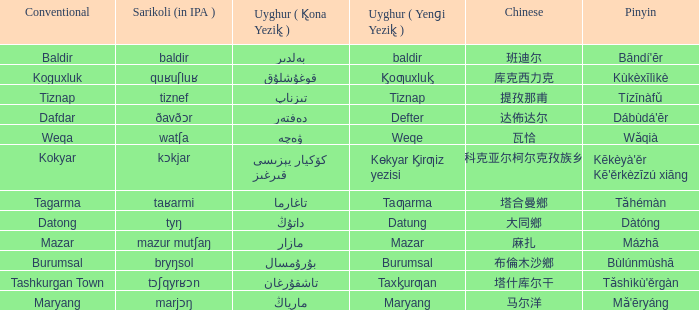Name the pinyin for  kɵkyar k̡irƣiz yezisi Kēkèyà'ěr Kē'ěrkèzīzú xiāng. 